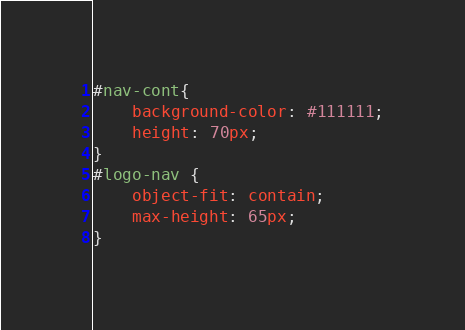<code> <loc_0><loc_0><loc_500><loc_500><_CSS_>
#nav-cont{
    background-color: #111111;
    height: 70px;
}
#logo-nav {
    object-fit: contain;
    max-height: 65px;
}</code> 